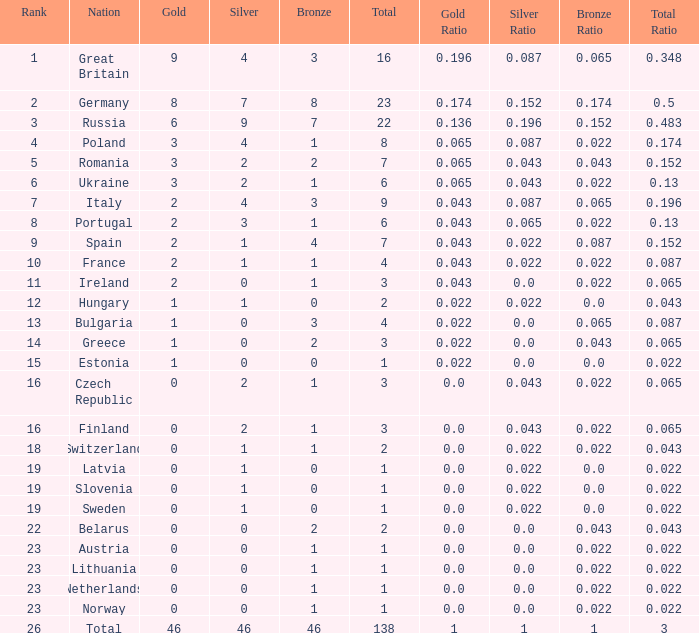When the total is larger than 1,and the bronze is less than 3, and silver larger than 2, and a gold larger than 2, what is the nation? Poland. Would you be able to parse every entry in this table? {'header': ['Rank', 'Nation', 'Gold', 'Silver', 'Bronze', 'Total', 'Gold Ratio', 'Silver Ratio', 'Bronze Ratio', 'Total Ratio'], 'rows': [['1', 'Great Britain', '9', '4', '3', '16', '0.196', '0.087', '0.065', '0.348'], ['2', 'Germany', '8', '7', '8', '23', '0.174', '0.152', '0.174', '0.5'], ['3', 'Russia', '6', '9', '7', '22', '0.136', '0.196', '0.152', '0.483'], ['4', 'Poland', '3', '4', '1', '8', '0.065', '0.087', '0.022', '0.174'], ['5', 'Romania', '3', '2', '2', '7', '0.065', '0.043', '0.043', '0.152'], ['6', 'Ukraine', '3', '2', '1', '6', '0.065', '0.043', '0.022', '0.13'], ['7', 'Italy', '2', '4', '3', '9', '0.043', '0.087', '0.065', '0.196'], ['8', 'Portugal', '2', '3', '1', '6', '0.043', '0.065', '0.022', '0.13'], ['9', 'Spain', '2', '1', '4', '7', '0.043', '0.022', '0.087', '0.152'], ['10', 'France', '2', '1', '1', '4', '0.043', '0.022', '0.022', '0.087'], ['11', 'Ireland', '2', '0', '1', '3', '0.043', '0.0', '0.022', '0.065'], ['12', 'Hungary', '1', '1', '0', '2', '0.022', '0.022', '0.0', '0.043'], ['13', 'Bulgaria', '1', '0', '3', '4', '0.022', '0.0', '0.065', '0.087'], ['14', 'Greece', '1', '0', '2', '3', '0.022', '0.0', '0.043', '0.065'], ['15', 'Estonia', '1', '0', '0', '1', '0.022', '0.0', '0.0', '0.022'], ['16', 'Czech Republic', '0', '2', '1', '3', '0.0', '0.043', '0.022', '0.065'], ['16', 'Finland', '0', '2', '1', '3', '0.0', '0.043', '0.022', '0.065'], ['18', 'Switzerland', '0', '1', '1', '2', '0.0', '0.022', '0.022', '0.043'], ['19', 'Latvia', '0', '1', '0', '1', '0.0', '0.022', '0.0', '0.022'], ['19', 'Slovenia', '0', '1', '0', '1', '0.0', '0.022', '0.0', '0.022'], ['19', 'Sweden', '0', '1', '0', '1', '0.0', '0.022', '0.0', '0.022'], ['22', 'Belarus', '0', '0', '2', '2', '0.0', '0.0', '0.043', '0.043'], ['23', 'Austria', '0', '0', '1', '1', '0.0', '0.0', '0.022', '0.022'], ['23', 'Lithuania', '0', '0', '1', '1', '0.0', '0.0', '0.022', '0.022'], ['23', 'Netherlands', '0', '0', '1', '1', '0.0', '0.0', '0.022', '0.022'], ['23', 'Norway', '0', '0', '1', '1', '0.0', '0.0', '0.022', '0.022'], ['26', 'Total', '46', '46', '46', '138', '1', '1', '1', '3']]} 